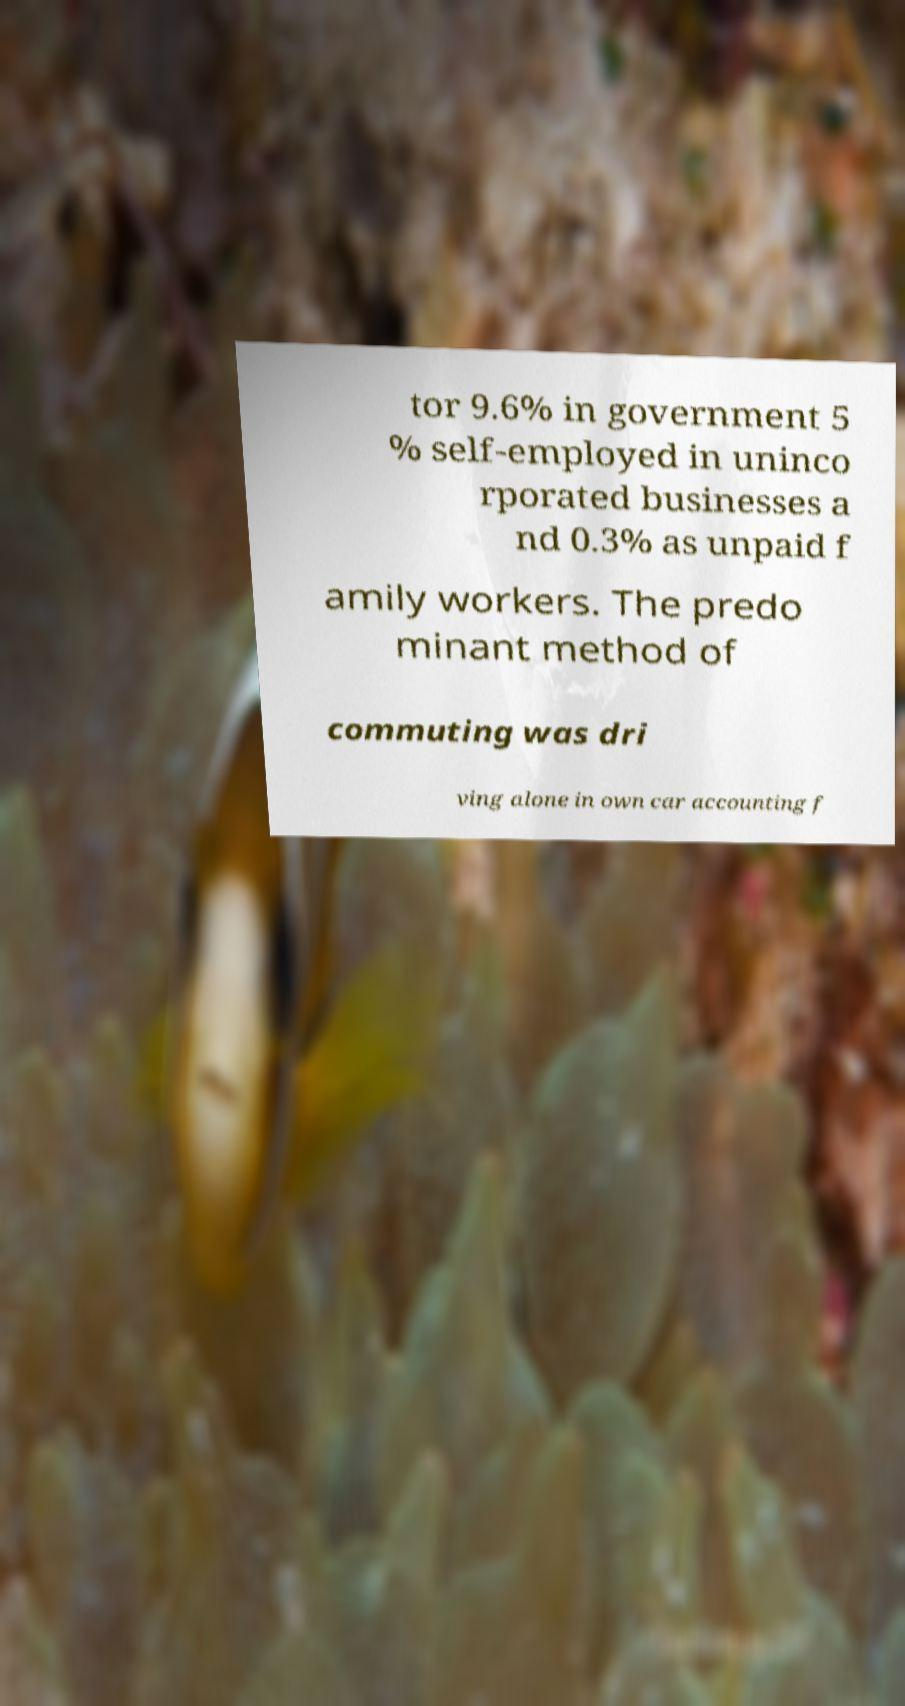For documentation purposes, I need the text within this image transcribed. Could you provide that? tor 9.6% in government 5 % self-employed in uninco rporated businesses a nd 0.3% as unpaid f amily workers. The predo minant method of commuting was dri ving alone in own car accounting f 